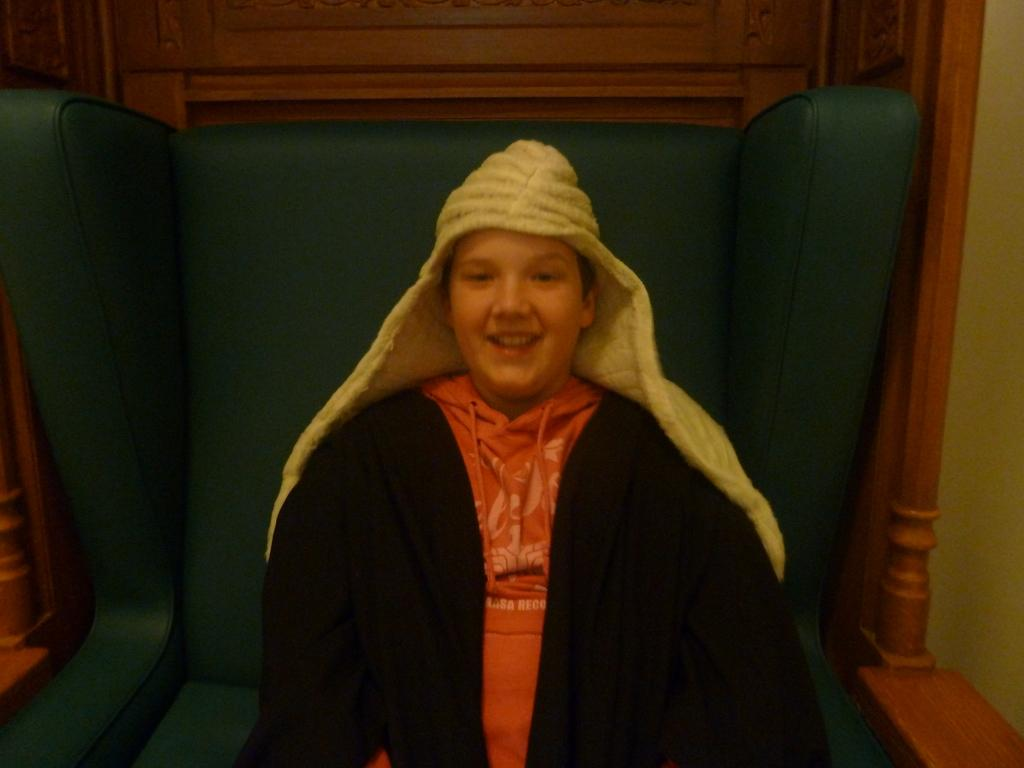Who or what is present in the image? There is a person in the image. What is the person doing in the image? The person is sitting in a sofa chair. How does the person appear to be feeling in the image? The person is smiling in the image. What type of art is displayed on the wall behind the person in the image? There is no information about any art displayed on the wall behind the person in the image. 